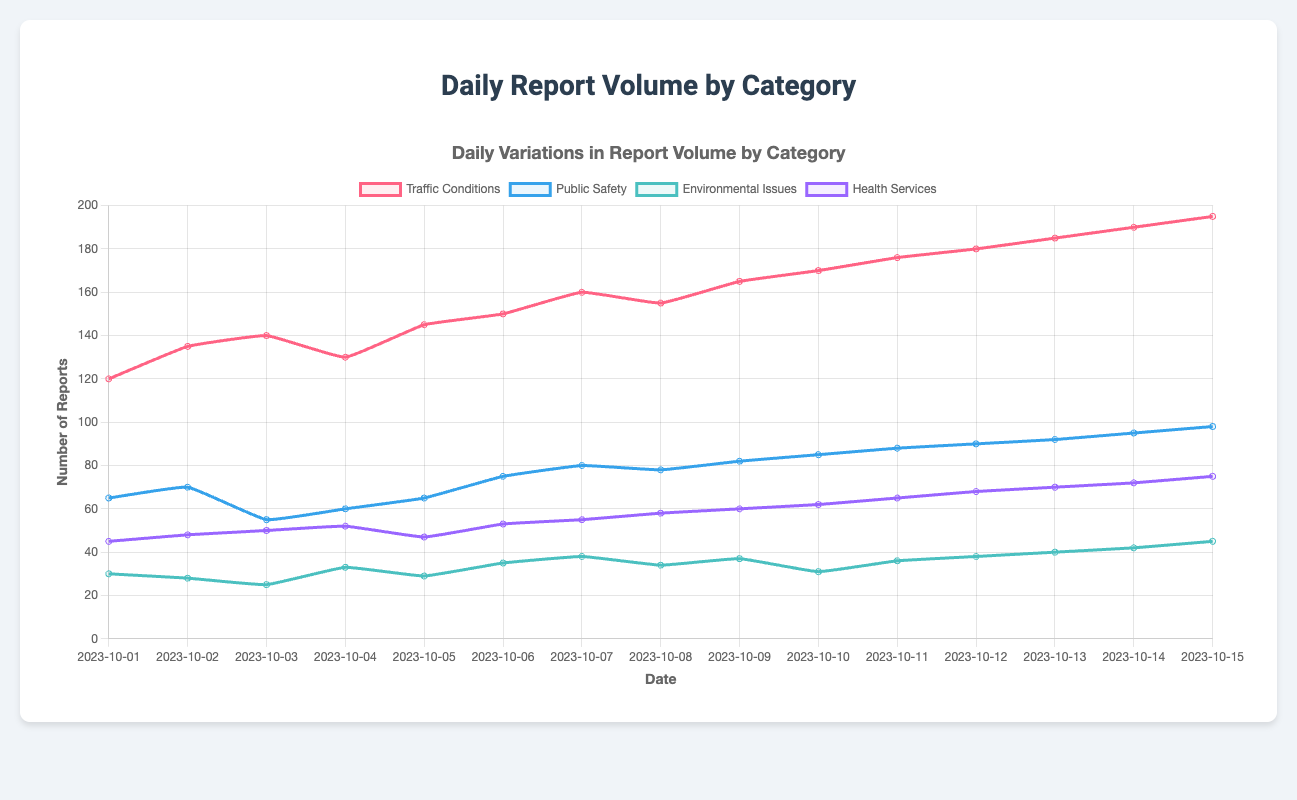How has the number of reports for Traffic Conditions changed over the period shown? To identify changes in the number of reports for Traffic Conditions, one should observe the red line representing Traffic Conditions. Starting from 120 on 2023-10-01, it gradually rises to 195 by 2023-10-15, showing a consistent increase over the period.
Answer: Increased Which day had the highest number of Public Safety reports? By identifying the highest point of the blue line for Public Safety, we observe that the peak occurs on 2023-10-15 with 98 reports.
Answer: 2023-10-15 On which date(s) did Environmental Issues reports reach or exceed 40? By looking at the points of the green line representing Environmental Issues, we observe values of 40 or more on 2023-10-13 (40), 2023-10-14 (42), and 2023-10-15 (45).
Answer: 2023-10-13, 2023-10-14, 2023-10-15 What is the difference in the number of Health Services reports between the first and last dates? To calculate the difference, refer to the purple line: on 2023-10-01, there are 45 reports, and on 2023-10-15, there are 75 reports. The difference is 75 - 45.
Answer: 30 Which category shows the most significant overall increase in reported volumes? To determine the most significant increase, compare the values from the start to the end date for all categories. Traffic Conditions increased from 120 to 195, Public Safety from 65 to 98, Environmental Issues from 30 to 45, and Health Services from 45 to 75. The increase is: Traffic Conditions = 75, Public Safety = 33, Environmental Issues = 15, Health Services = 30. Traffic Conditions has the highest increase.
Answer: Traffic Conditions Compare the number of reports for Public Safety and Health Services on 2023-10-05. On 2023-10-05, the blue line (Public Safety) is at 65, and the purple line (Health Services) is at 47. Comparing these values, Public Safety is greater.
Answer: Public Safety What is the total number of Traffic Conditions reports during the first three days? Sum the values of Traffic Conditions for 2023-10-01, 2023-10-02, and 2023-10-03: 120 + 135 + 140.
Answer: 395 On which date did Environmental Issues reports drop to their lowest? Identify the lowest point of the green line. The value of 25 on 2023-10-03 is the lowest for Environmental Issues.
Answer: 2023-10-03 How do the maximum values of reports for Health Services and Environmental Issues compare? The maximum value for Health Services (purple line) reaches 75 on 2023-10-15. The maximum for Environmental Issues (green line) is 45, also on 2023-10-15. Comparing these values shows that Health Services is greater.
Answer: Health Services is greater 